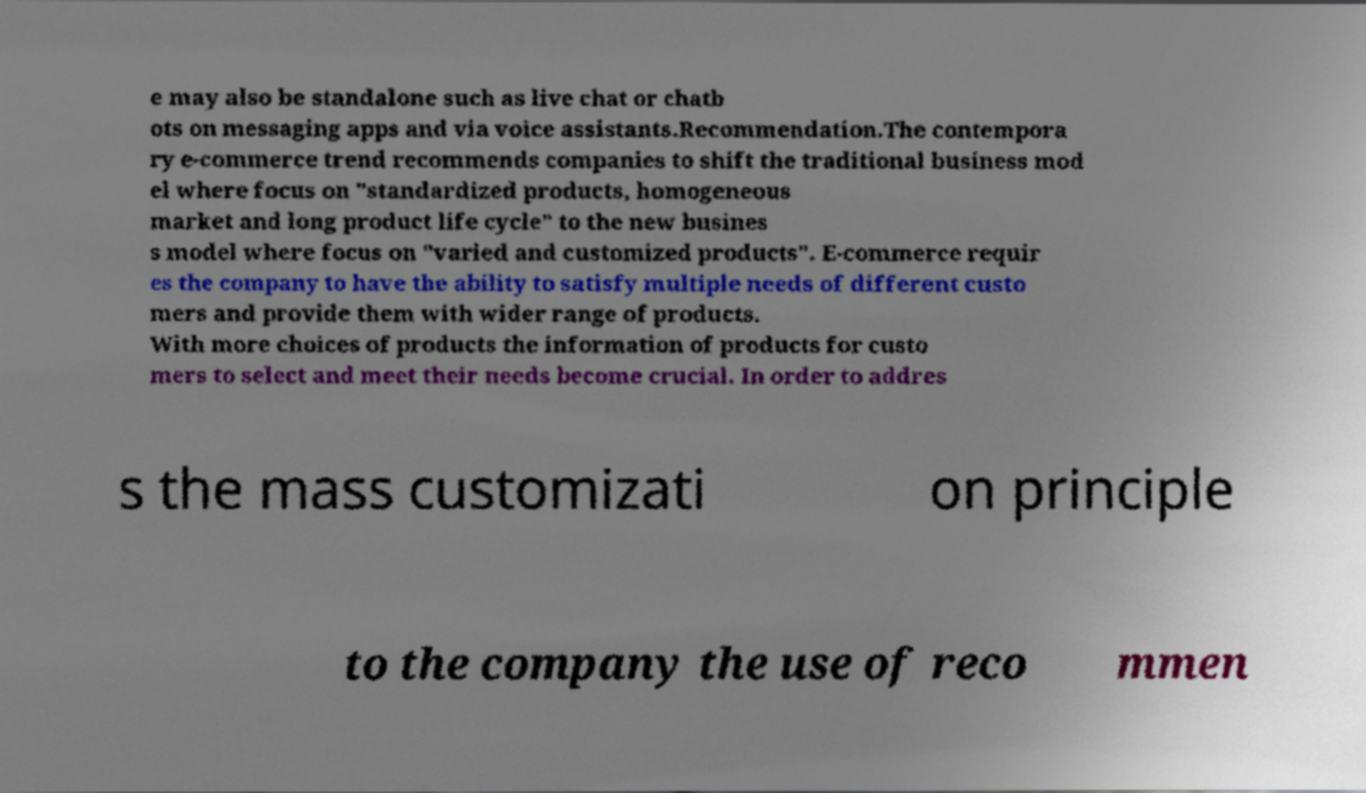Can you read and provide the text displayed in the image?This photo seems to have some interesting text. Can you extract and type it out for me? e may also be standalone such as live chat or chatb ots on messaging apps and via voice assistants.Recommendation.The contempora ry e-commerce trend recommends companies to shift the traditional business mod el where focus on "standardized products, homogeneous market and long product life cycle" to the new busines s model where focus on "varied and customized products". E-commerce requir es the company to have the ability to satisfy multiple needs of different custo mers and provide them with wider range of products. With more choices of products the information of products for custo mers to select and meet their needs become crucial. In order to addres s the mass customizati on principle to the company the use of reco mmen 